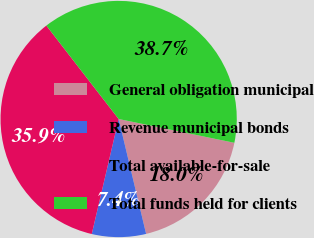Convert chart to OTSL. <chart><loc_0><loc_0><loc_500><loc_500><pie_chart><fcel>General obligation municipal<fcel>Revenue municipal bonds<fcel>Total available-for-sale<fcel>Total funds held for clients<nl><fcel>18.04%<fcel>7.39%<fcel>35.86%<fcel>38.71%<nl></chart> 